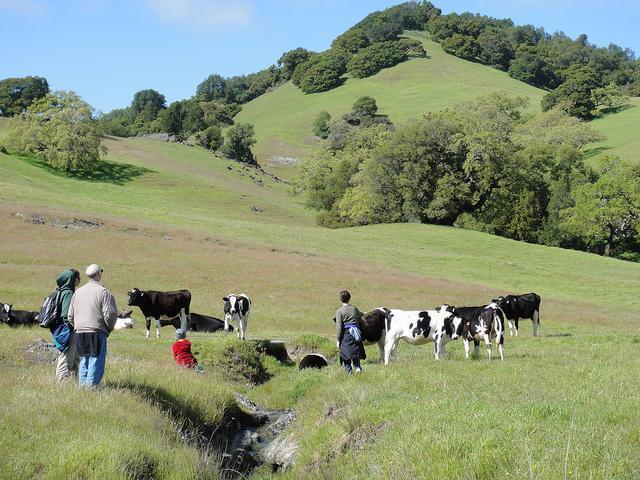How many people are in the photo?
Give a very brief answer. 2. 